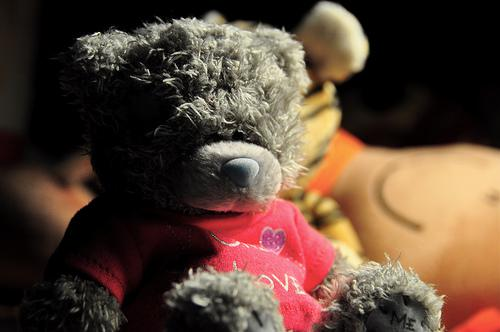Question: what is the subject of this picture?
Choices:
A. Dog.
B. Cat.
C. Baby.
D. A Teddy bear.
Answer with the letter. Answer: D Question: how many of the bear's eyes are visible?
Choices:
A. None.
B. One.
C. Two.
D. Three.
Answer with the letter. Answer: A Question: what is behind the bear?
Choices:
A. Stuffed animals.
B. Doll.
C. Toy truck.
D. Cat.
Answer with the letter. Answer: A Question: what color is the bear?
Choices:
A. Yellow.
B. Brown.
C. Gray.
D. Black.
Answer with the letter. Answer: C Question: what color is the bear's nose?
Choices:
A. Black.
B. Brown.
C. Pink.
D. Gray.
Answer with the letter. Answer: D 